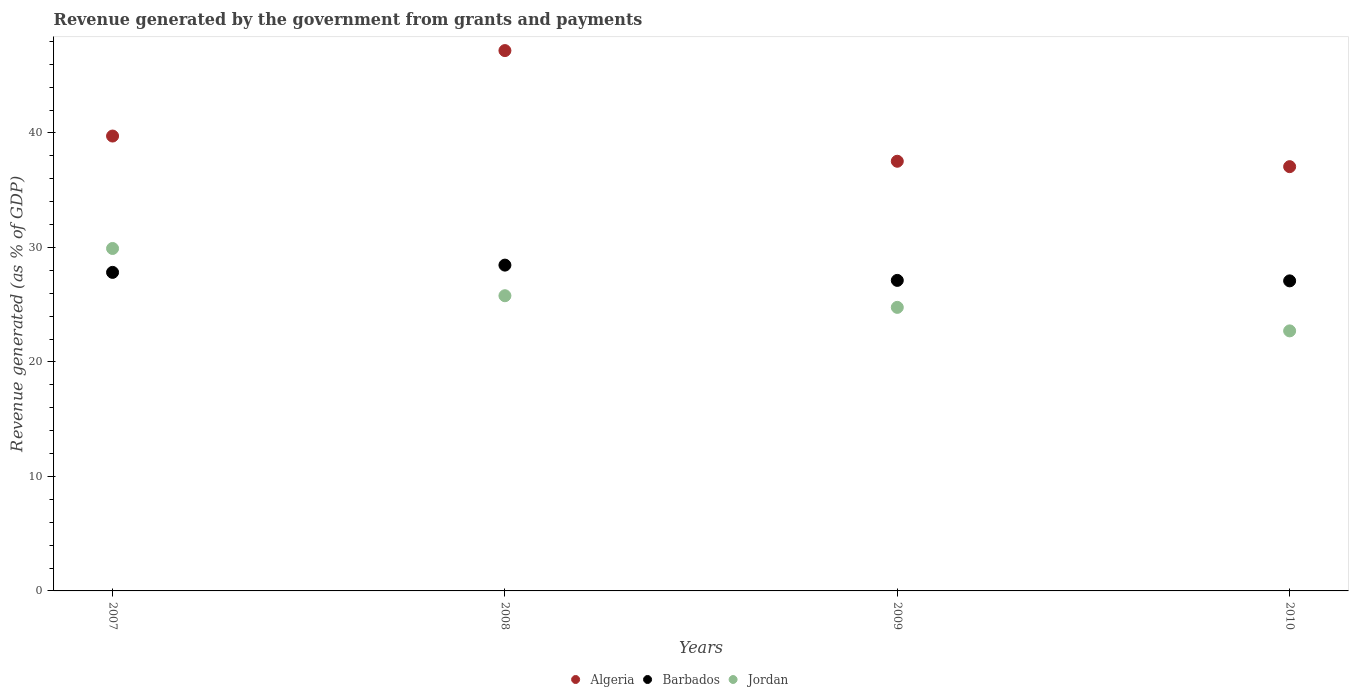How many different coloured dotlines are there?
Offer a terse response. 3. What is the revenue generated by the government in Barbados in 2007?
Provide a succinct answer. 27.82. Across all years, what is the maximum revenue generated by the government in Algeria?
Provide a short and direct response. 47.19. Across all years, what is the minimum revenue generated by the government in Algeria?
Give a very brief answer. 37.05. In which year was the revenue generated by the government in Jordan maximum?
Provide a succinct answer. 2007. In which year was the revenue generated by the government in Jordan minimum?
Your answer should be very brief. 2010. What is the total revenue generated by the government in Algeria in the graph?
Offer a terse response. 161.5. What is the difference between the revenue generated by the government in Barbados in 2008 and that in 2009?
Your answer should be very brief. 1.33. What is the difference between the revenue generated by the government in Barbados in 2008 and the revenue generated by the government in Algeria in 2009?
Your answer should be compact. -9.07. What is the average revenue generated by the government in Jordan per year?
Ensure brevity in your answer.  25.79. In the year 2008, what is the difference between the revenue generated by the government in Barbados and revenue generated by the government in Jordan?
Your answer should be compact. 2.67. In how many years, is the revenue generated by the government in Barbados greater than 6 %?
Your answer should be very brief. 4. What is the ratio of the revenue generated by the government in Algeria in 2008 to that in 2010?
Provide a short and direct response. 1.27. Is the difference between the revenue generated by the government in Barbados in 2007 and 2010 greater than the difference between the revenue generated by the government in Jordan in 2007 and 2010?
Give a very brief answer. No. What is the difference between the highest and the second highest revenue generated by the government in Jordan?
Ensure brevity in your answer.  4.13. What is the difference between the highest and the lowest revenue generated by the government in Jordan?
Provide a short and direct response. 7.2. In how many years, is the revenue generated by the government in Algeria greater than the average revenue generated by the government in Algeria taken over all years?
Your response must be concise. 1. Is it the case that in every year, the sum of the revenue generated by the government in Algeria and revenue generated by the government in Jordan  is greater than the revenue generated by the government in Barbados?
Make the answer very short. Yes. Does the revenue generated by the government in Algeria monotonically increase over the years?
Ensure brevity in your answer.  No. Is the revenue generated by the government in Jordan strictly less than the revenue generated by the government in Barbados over the years?
Make the answer very short. No. How many dotlines are there?
Make the answer very short. 3. What is the difference between two consecutive major ticks on the Y-axis?
Make the answer very short. 10. Are the values on the major ticks of Y-axis written in scientific E-notation?
Your response must be concise. No. Does the graph contain any zero values?
Offer a terse response. No. Does the graph contain grids?
Keep it short and to the point. No. What is the title of the graph?
Your response must be concise. Revenue generated by the government from grants and payments. Does "Iran" appear as one of the legend labels in the graph?
Your answer should be very brief. No. What is the label or title of the X-axis?
Offer a terse response. Years. What is the label or title of the Y-axis?
Provide a short and direct response. Revenue generated (as % of GDP). What is the Revenue generated (as % of GDP) of Algeria in 2007?
Keep it short and to the point. 39.73. What is the Revenue generated (as % of GDP) of Barbados in 2007?
Provide a succinct answer. 27.82. What is the Revenue generated (as % of GDP) in Jordan in 2007?
Offer a terse response. 29.91. What is the Revenue generated (as % of GDP) of Algeria in 2008?
Your answer should be compact. 47.19. What is the Revenue generated (as % of GDP) in Barbados in 2008?
Provide a short and direct response. 28.45. What is the Revenue generated (as % of GDP) in Jordan in 2008?
Give a very brief answer. 25.78. What is the Revenue generated (as % of GDP) in Algeria in 2009?
Your response must be concise. 37.53. What is the Revenue generated (as % of GDP) of Barbados in 2009?
Ensure brevity in your answer.  27.12. What is the Revenue generated (as % of GDP) of Jordan in 2009?
Offer a very short reply. 24.76. What is the Revenue generated (as % of GDP) in Algeria in 2010?
Your response must be concise. 37.05. What is the Revenue generated (as % of GDP) of Barbados in 2010?
Your answer should be compact. 27.08. What is the Revenue generated (as % of GDP) in Jordan in 2010?
Your answer should be compact. 22.71. Across all years, what is the maximum Revenue generated (as % of GDP) in Algeria?
Ensure brevity in your answer.  47.19. Across all years, what is the maximum Revenue generated (as % of GDP) of Barbados?
Offer a terse response. 28.45. Across all years, what is the maximum Revenue generated (as % of GDP) in Jordan?
Your response must be concise. 29.91. Across all years, what is the minimum Revenue generated (as % of GDP) of Algeria?
Offer a terse response. 37.05. Across all years, what is the minimum Revenue generated (as % of GDP) in Barbados?
Provide a short and direct response. 27.08. Across all years, what is the minimum Revenue generated (as % of GDP) of Jordan?
Your response must be concise. 22.71. What is the total Revenue generated (as % of GDP) in Algeria in the graph?
Offer a very short reply. 161.5. What is the total Revenue generated (as % of GDP) of Barbados in the graph?
Give a very brief answer. 110.47. What is the total Revenue generated (as % of GDP) of Jordan in the graph?
Provide a succinct answer. 103.16. What is the difference between the Revenue generated (as % of GDP) in Algeria in 2007 and that in 2008?
Offer a terse response. -7.46. What is the difference between the Revenue generated (as % of GDP) of Barbados in 2007 and that in 2008?
Ensure brevity in your answer.  -0.63. What is the difference between the Revenue generated (as % of GDP) in Jordan in 2007 and that in 2008?
Provide a short and direct response. 4.13. What is the difference between the Revenue generated (as % of GDP) in Algeria in 2007 and that in 2009?
Provide a short and direct response. 2.2. What is the difference between the Revenue generated (as % of GDP) of Barbados in 2007 and that in 2009?
Provide a short and direct response. 0.7. What is the difference between the Revenue generated (as % of GDP) of Jordan in 2007 and that in 2009?
Give a very brief answer. 5.14. What is the difference between the Revenue generated (as % of GDP) in Algeria in 2007 and that in 2010?
Your answer should be compact. 2.67. What is the difference between the Revenue generated (as % of GDP) in Barbados in 2007 and that in 2010?
Your answer should be very brief. 0.74. What is the difference between the Revenue generated (as % of GDP) of Jordan in 2007 and that in 2010?
Your answer should be very brief. 7.2. What is the difference between the Revenue generated (as % of GDP) of Algeria in 2008 and that in 2009?
Your response must be concise. 9.66. What is the difference between the Revenue generated (as % of GDP) of Barbados in 2008 and that in 2009?
Your answer should be compact. 1.33. What is the difference between the Revenue generated (as % of GDP) of Jordan in 2008 and that in 2009?
Offer a terse response. 1.02. What is the difference between the Revenue generated (as % of GDP) of Algeria in 2008 and that in 2010?
Give a very brief answer. 10.14. What is the difference between the Revenue generated (as % of GDP) in Barbados in 2008 and that in 2010?
Your response must be concise. 1.38. What is the difference between the Revenue generated (as % of GDP) in Jordan in 2008 and that in 2010?
Your answer should be very brief. 3.07. What is the difference between the Revenue generated (as % of GDP) of Algeria in 2009 and that in 2010?
Your answer should be very brief. 0.47. What is the difference between the Revenue generated (as % of GDP) of Barbados in 2009 and that in 2010?
Provide a short and direct response. 0.04. What is the difference between the Revenue generated (as % of GDP) of Jordan in 2009 and that in 2010?
Your response must be concise. 2.05. What is the difference between the Revenue generated (as % of GDP) of Algeria in 2007 and the Revenue generated (as % of GDP) of Barbados in 2008?
Ensure brevity in your answer.  11.27. What is the difference between the Revenue generated (as % of GDP) of Algeria in 2007 and the Revenue generated (as % of GDP) of Jordan in 2008?
Your answer should be very brief. 13.95. What is the difference between the Revenue generated (as % of GDP) in Barbados in 2007 and the Revenue generated (as % of GDP) in Jordan in 2008?
Offer a very short reply. 2.04. What is the difference between the Revenue generated (as % of GDP) in Algeria in 2007 and the Revenue generated (as % of GDP) in Barbados in 2009?
Keep it short and to the point. 12.61. What is the difference between the Revenue generated (as % of GDP) of Algeria in 2007 and the Revenue generated (as % of GDP) of Jordan in 2009?
Offer a very short reply. 14.96. What is the difference between the Revenue generated (as % of GDP) in Barbados in 2007 and the Revenue generated (as % of GDP) in Jordan in 2009?
Your answer should be very brief. 3.06. What is the difference between the Revenue generated (as % of GDP) in Algeria in 2007 and the Revenue generated (as % of GDP) in Barbados in 2010?
Give a very brief answer. 12.65. What is the difference between the Revenue generated (as % of GDP) of Algeria in 2007 and the Revenue generated (as % of GDP) of Jordan in 2010?
Offer a very short reply. 17.02. What is the difference between the Revenue generated (as % of GDP) in Barbados in 2007 and the Revenue generated (as % of GDP) in Jordan in 2010?
Your answer should be compact. 5.11. What is the difference between the Revenue generated (as % of GDP) in Algeria in 2008 and the Revenue generated (as % of GDP) in Barbados in 2009?
Your answer should be compact. 20.07. What is the difference between the Revenue generated (as % of GDP) of Algeria in 2008 and the Revenue generated (as % of GDP) of Jordan in 2009?
Give a very brief answer. 22.43. What is the difference between the Revenue generated (as % of GDP) of Barbados in 2008 and the Revenue generated (as % of GDP) of Jordan in 2009?
Offer a very short reply. 3.69. What is the difference between the Revenue generated (as % of GDP) in Algeria in 2008 and the Revenue generated (as % of GDP) in Barbados in 2010?
Your answer should be very brief. 20.11. What is the difference between the Revenue generated (as % of GDP) in Algeria in 2008 and the Revenue generated (as % of GDP) in Jordan in 2010?
Give a very brief answer. 24.48. What is the difference between the Revenue generated (as % of GDP) in Barbados in 2008 and the Revenue generated (as % of GDP) in Jordan in 2010?
Make the answer very short. 5.74. What is the difference between the Revenue generated (as % of GDP) of Algeria in 2009 and the Revenue generated (as % of GDP) of Barbados in 2010?
Provide a succinct answer. 10.45. What is the difference between the Revenue generated (as % of GDP) in Algeria in 2009 and the Revenue generated (as % of GDP) in Jordan in 2010?
Offer a terse response. 14.81. What is the difference between the Revenue generated (as % of GDP) of Barbados in 2009 and the Revenue generated (as % of GDP) of Jordan in 2010?
Provide a succinct answer. 4.41. What is the average Revenue generated (as % of GDP) of Algeria per year?
Give a very brief answer. 40.37. What is the average Revenue generated (as % of GDP) of Barbados per year?
Ensure brevity in your answer.  27.62. What is the average Revenue generated (as % of GDP) in Jordan per year?
Offer a terse response. 25.79. In the year 2007, what is the difference between the Revenue generated (as % of GDP) of Algeria and Revenue generated (as % of GDP) of Barbados?
Offer a very short reply. 11.91. In the year 2007, what is the difference between the Revenue generated (as % of GDP) in Algeria and Revenue generated (as % of GDP) in Jordan?
Offer a terse response. 9.82. In the year 2007, what is the difference between the Revenue generated (as % of GDP) of Barbados and Revenue generated (as % of GDP) of Jordan?
Ensure brevity in your answer.  -2.09. In the year 2008, what is the difference between the Revenue generated (as % of GDP) of Algeria and Revenue generated (as % of GDP) of Barbados?
Ensure brevity in your answer.  18.74. In the year 2008, what is the difference between the Revenue generated (as % of GDP) of Algeria and Revenue generated (as % of GDP) of Jordan?
Give a very brief answer. 21.41. In the year 2008, what is the difference between the Revenue generated (as % of GDP) in Barbados and Revenue generated (as % of GDP) in Jordan?
Ensure brevity in your answer.  2.67. In the year 2009, what is the difference between the Revenue generated (as % of GDP) in Algeria and Revenue generated (as % of GDP) in Barbados?
Give a very brief answer. 10.41. In the year 2009, what is the difference between the Revenue generated (as % of GDP) in Algeria and Revenue generated (as % of GDP) in Jordan?
Ensure brevity in your answer.  12.76. In the year 2009, what is the difference between the Revenue generated (as % of GDP) in Barbados and Revenue generated (as % of GDP) in Jordan?
Your answer should be very brief. 2.36. In the year 2010, what is the difference between the Revenue generated (as % of GDP) of Algeria and Revenue generated (as % of GDP) of Barbados?
Your answer should be very brief. 9.98. In the year 2010, what is the difference between the Revenue generated (as % of GDP) of Algeria and Revenue generated (as % of GDP) of Jordan?
Make the answer very short. 14.34. In the year 2010, what is the difference between the Revenue generated (as % of GDP) of Barbados and Revenue generated (as % of GDP) of Jordan?
Give a very brief answer. 4.37. What is the ratio of the Revenue generated (as % of GDP) of Algeria in 2007 to that in 2008?
Offer a terse response. 0.84. What is the ratio of the Revenue generated (as % of GDP) of Barbados in 2007 to that in 2008?
Keep it short and to the point. 0.98. What is the ratio of the Revenue generated (as % of GDP) in Jordan in 2007 to that in 2008?
Keep it short and to the point. 1.16. What is the ratio of the Revenue generated (as % of GDP) in Algeria in 2007 to that in 2009?
Give a very brief answer. 1.06. What is the ratio of the Revenue generated (as % of GDP) in Barbados in 2007 to that in 2009?
Your response must be concise. 1.03. What is the ratio of the Revenue generated (as % of GDP) of Jordan in 2007 to that in 2009?
Offer a terse response. 1.21. What is the ratio of the Revenue generated (as % of GDP) in Algeria in 2007 to that in 2010?
Ensure brevity in your answer.  1.07. What is the ratio of the Revenue generated (as % of GDP) of Barbados in 2007 to that in 2010?
Provide a succinct answer. 1.03. What is the ratio of the Revenue generated (as % of GDP) of Jordan in 2007 to that in 2010?
Make the answer very short. 1.32. What is the ratio of the Revenue generated (as % of GDP) of Algeria in 2008 to that in 2009?
Your answer should be compact. 1.26. What is the ratio of the Revenue generated (as % of GDP) in Barbados in 2008 to that in 2009?
Make the answer very short. 1.05. What is the ratio of the Revenue generated (as % of GDP) in Jordan in 2008 to that in 2009?
Make the answer very short. 1.04. What is the ratio of the Revenue generated (as % of GDP) of Algeria in 2008 to that in 2010?
Ensure brevity in your answer.  1.27. What is the ratio of the Revenue generated (as % of GDP) of Barbados in 2008 to that in 2010?
Keep it short and to the point. 1.05. What is the ratio of the Revenue generated (as % of GDP) of Jordan in 2008 to that in 2010?
Your answer should be compact. 1.14. What is the ratio of the Revenue generated (as % of GDP) in Algeria in 2009 to that in 2010?
Your response must be concise. 1.01. What is the ratio of the Revenue generated (as % of GDP) in Jordan in 2009 to that in 2010?
Your answer should be very brief. 1.09. What is the difference between the highest and the second highest Revenue generated (as % of GDP) of Algeria?
Make the answer very short. 7.46. What is the difference between the highest and the second highest Revenue generated (as % of GDP) of Barbados?
Provide a succinct answer. 0.63. What is the difference between the highest and the second highest Revenue generated (as % of GDP) in Jordan?
Your answer should be very brief. 4.13. What is the difference between the highest and the lowest Revenue generated (as % of GDP) in Algeria?
Offer a terse response. 10.14. What is the difference between the highest and the lowest Revenue generated (as % of GDP) in Barbados?
Offer a very short reply. 1.38. What is the difference between the highest and the lowest Revenue generated (as % of GDP) in Jordan?
Make the answer very short. 7.2. 